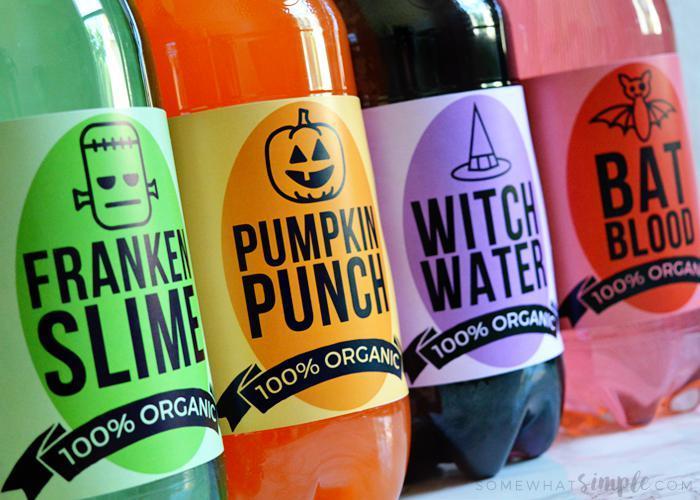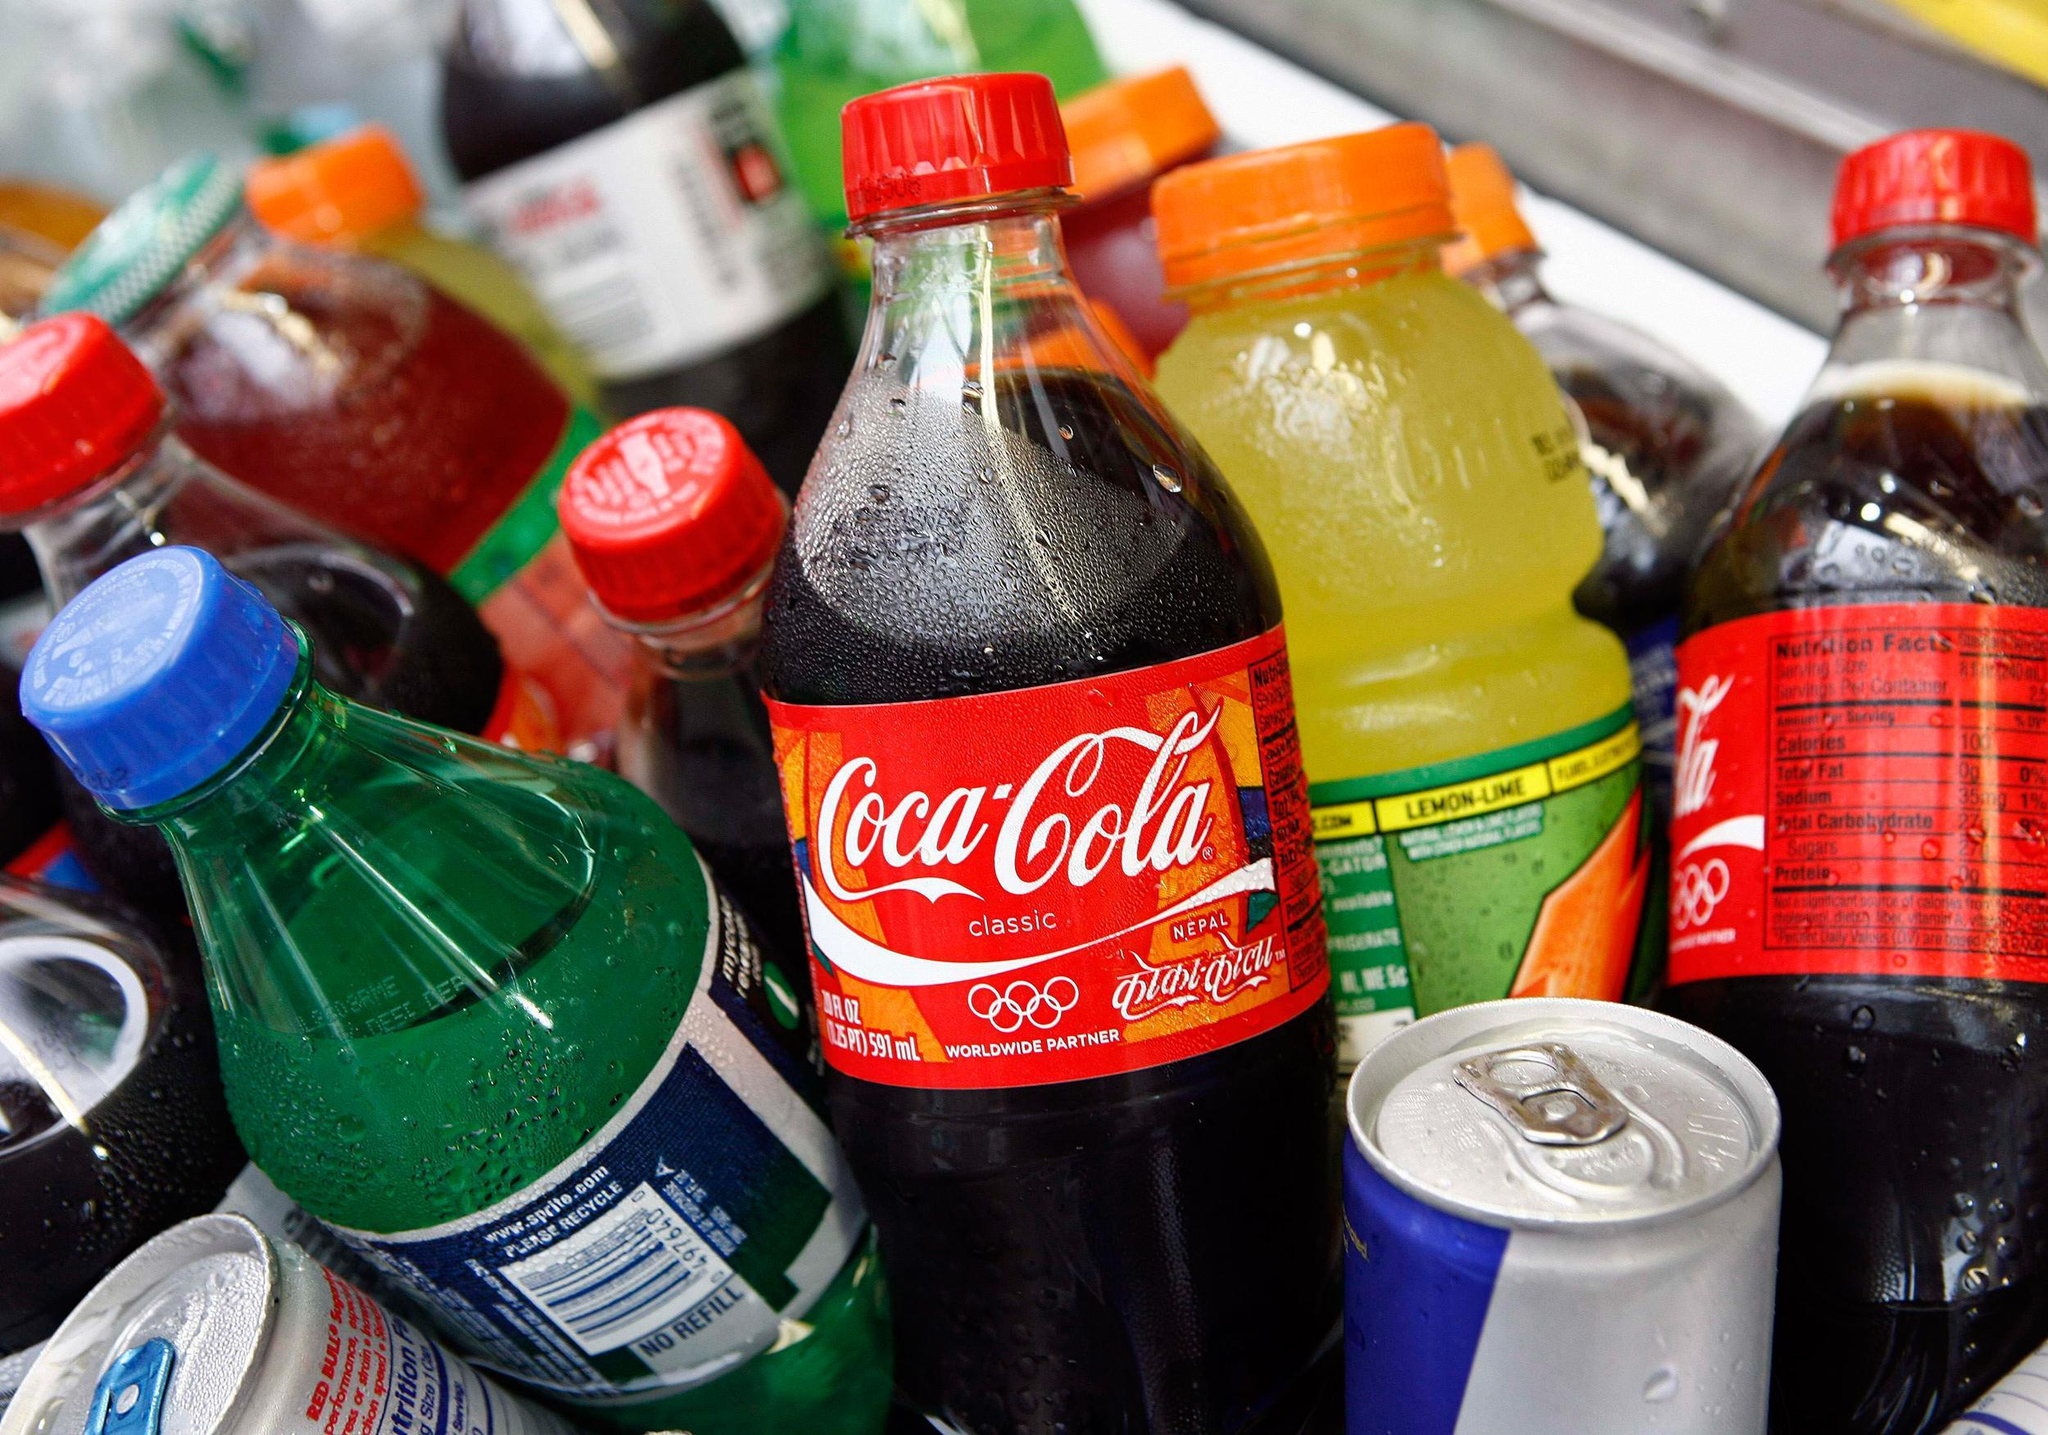The first image is the image on the left, the second image is the image on the right. Given the left and right images, does the statement "There are only three bottles visible in one of the images." hold true? Answer yes or no. No. The first image is the image on the left, the second image is the image on the right. Considering the images on both sides, is "The image on the left shows four bottles, each containing a different kind of an organic drink, each with a Halloween name." valid? Answer yes or no. Yes. 